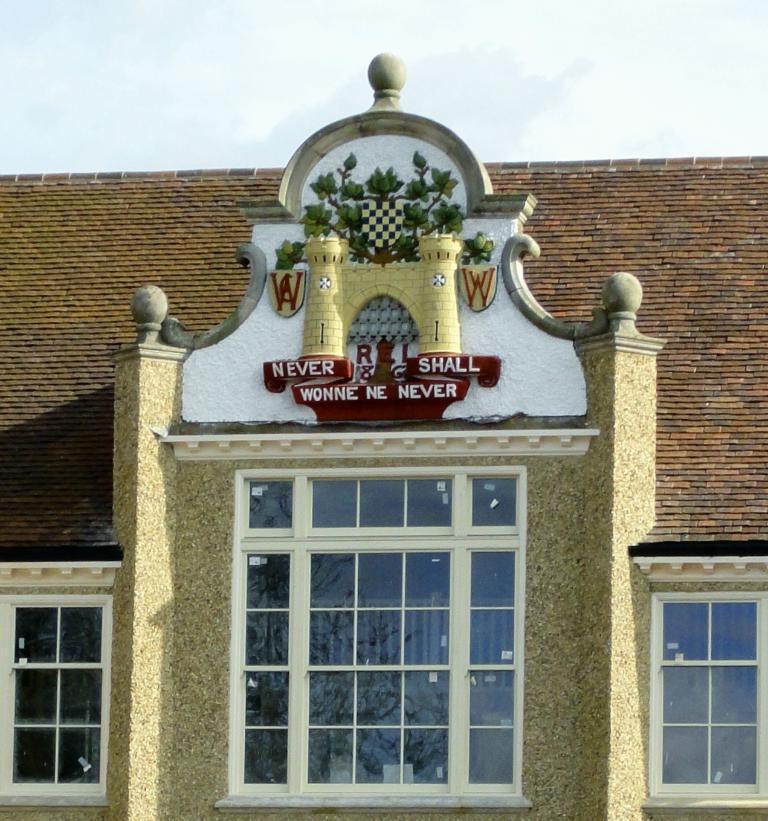Can you describe this image briefly? In this image I can see a building. I can see windows. I can see some text. At the top I can see clouds in the sky. 